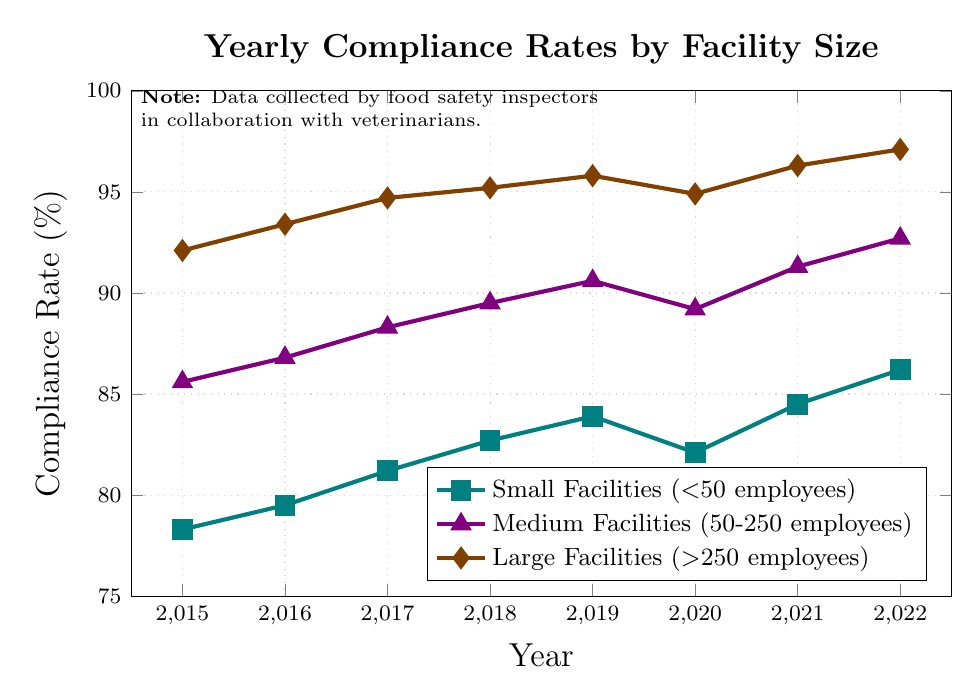What is the compliance rate of large facilities in 2019? Look at the line corresponding to large facilities and find the 2019 data point. The y-value gives the compliance rate.
Answer: 95.8% Which size of facilities showed the highest compliance rate in 2021? Compare the compliance rates of small, medium, and large facilities for the year 2021, identifying the highest value.
Answer: Large Facilities Did the compliance rate of medium facilities increase or decrease from 2020 to 2021? Compare the compliance rates of medium facilities from 2020 (89.2%) and 2021 (91.3%). The rate increased.
Answer: Increased Calculate the average compliance rate of small facilities from 2015 to 2017. Sum the compliance rates of small facilities for 2015, 2016, and 2017, and divide by 3: (78.3 + 79.5 + 81.2) / 3 = 79.67
Answer: 79.67 What is the difference in compliance rates between medium and large facilities in 2022? Find the compliance rates for medium (92.7%) and large (97.1%) facilities in 2022, then subtract the medium facility rate from the large facility rate: 97.1 - 92.7 = 4.4
Answer: 4.4 Which facilities exhibited a decrease in compliance rate from 2019 to 2020? Compare the compliance rates for 2019 and 2020 for all facility sizes: small facilities (83.9 to 82.1), medium facilities (90.6 to 89.2), large facilities (95.8 to 94.9). All showed a decrease.
Answer: Small, Medium, Large Facilities What color represents small facilities in the chart? Look at the legend and find the color corresponding to "Small Facilities (<50 employees)". The line is colored teal.
Answer: Teal Between which consecutive years did the compliance rate of small facilities show the largest increase? Calculate the year-over-year increases for small facilities: 1.2 (from 2015 to 2016), 1.7 (from 2016 to 2017), 1.5 (from 2017 to 2018), 1.2 (from 2018 to 2019), -1.8 (from 2019 to 2020), 2.4 (from 2020 to 2021), 1.7 (from 2021 to 2022). The largest increase is 2.4, from 2020 to 2021.
Answer: 2020 to 2021 